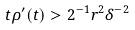<formula> <loc_0><loc_0><loc_500><loc_500>t \rho ^ { \prime } ( t ) > 2 ^ { - 1 } r ^ { 2 } \delta ^ { - 2 }</formula> 